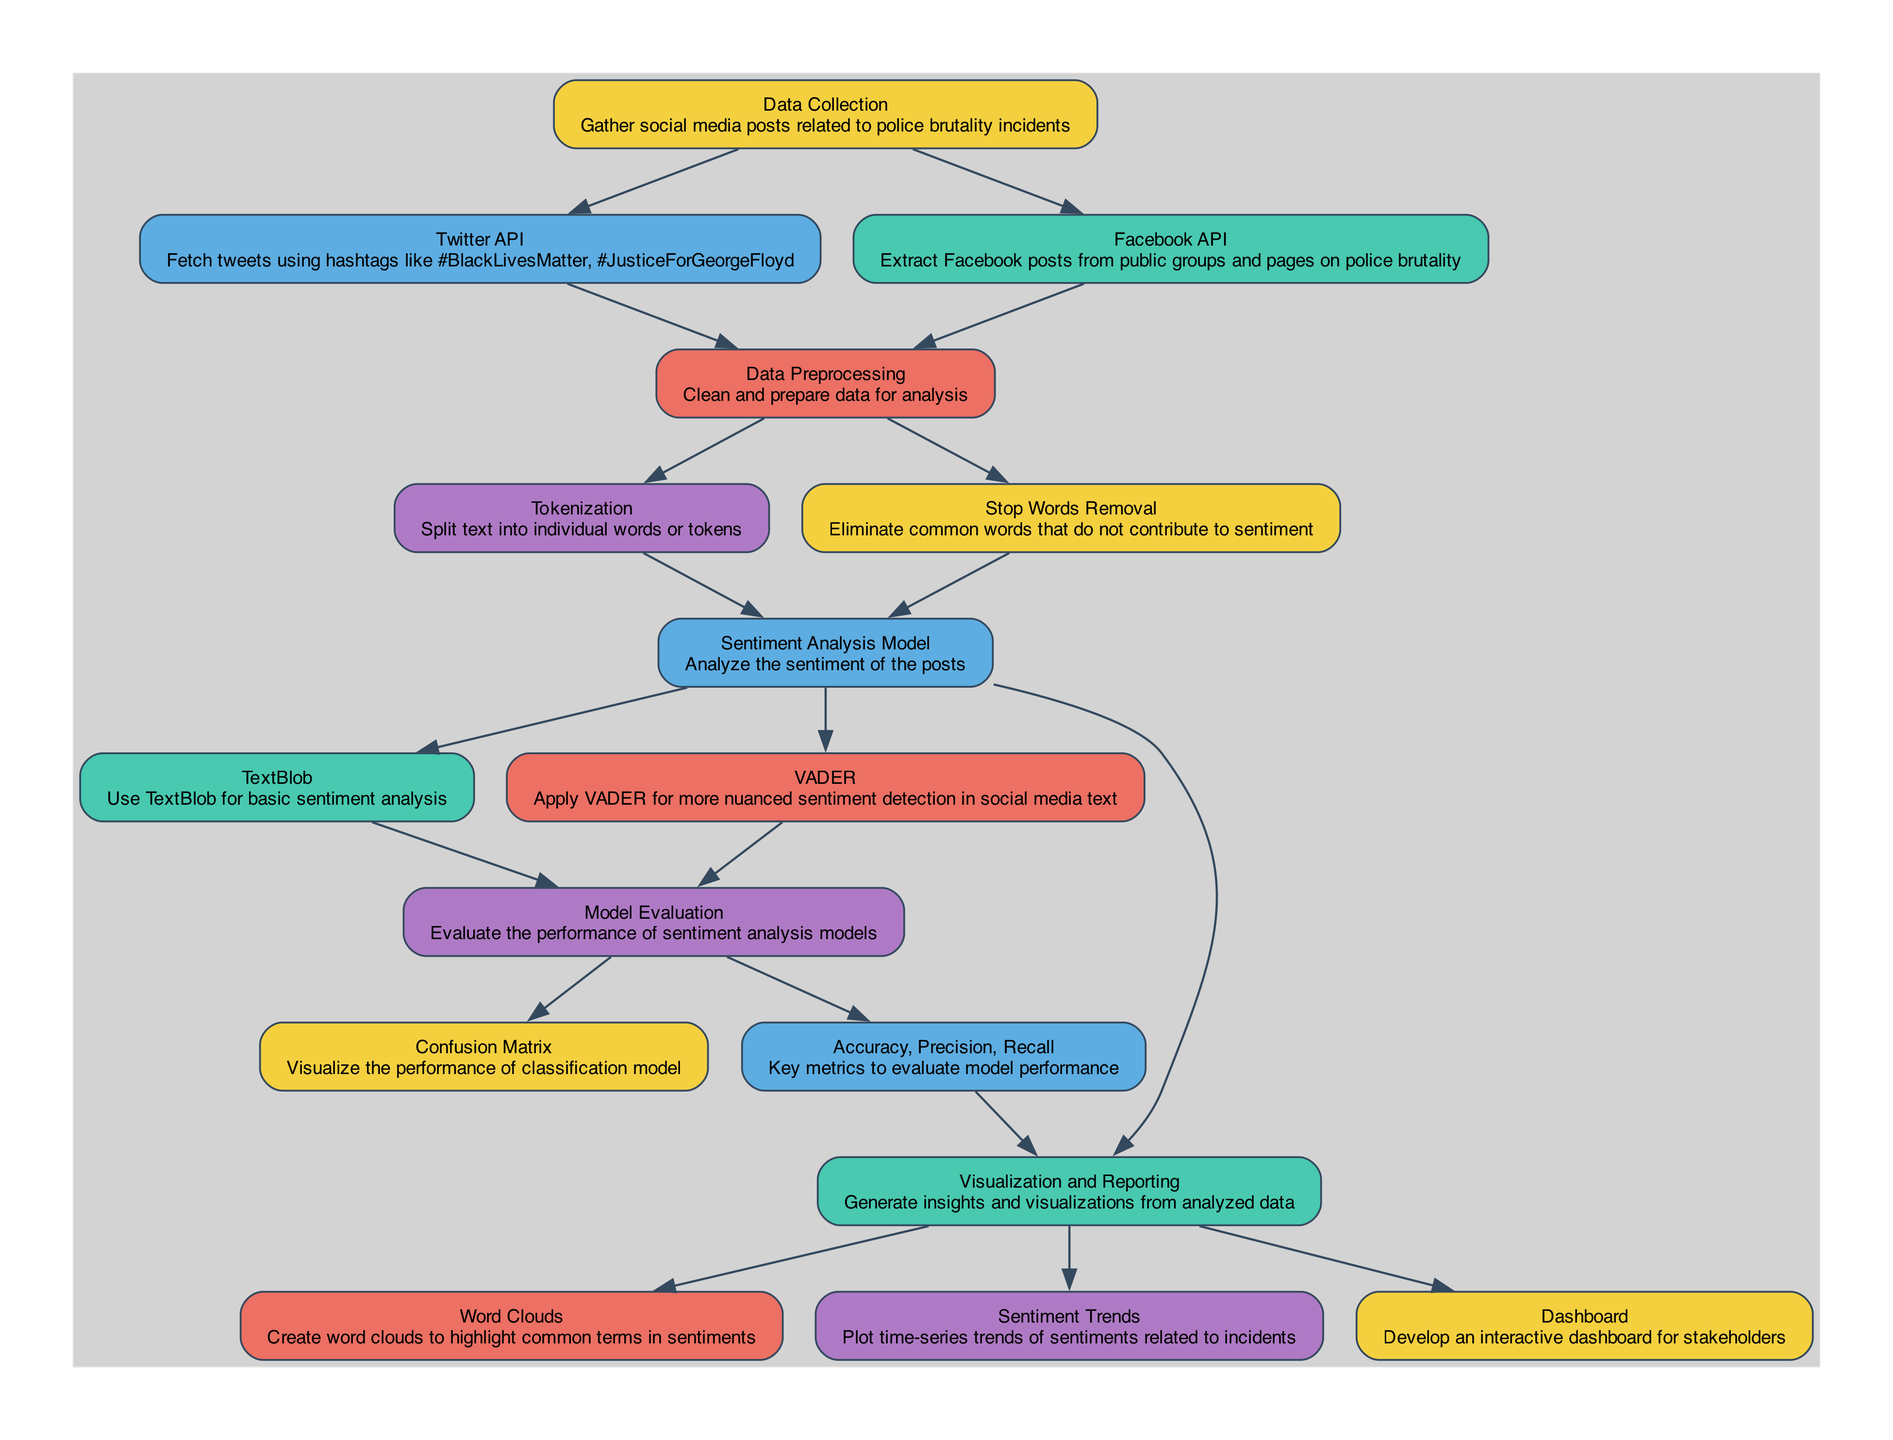What is the first step in the process? The diagram indicates that "Data Collection" is the first node, which involves gathering social media posts related to police brutality incidents.
Answer: Data Collection How many nodes are there in total? Counting the nodes listed in the diagram, there are 16 nodes representing different stages in the sentiment analysis process.
Answer: 16 What is the relationship between Data Preprocessing and Tokenization? Data Preprocessing is a prerequisite for Tokenization as indicated by the edge that connects the two, showing that preprocessing must occur before tokenization can take place.
Answer: Data Preprocessing → Tokenization Which sentiment analysis model uses TextBlob? The diagram shows that TextBlob is part of the sentiment analysis process that follows the "Sentiment Analysis Model," which uses TextBlob for basic sentiment analysis.
Answer: TextBlob What metrics are used for model evaluation? The metrics for evaluating model performance include Accuracy, Precision, and Recall, as specified by the node that elaborates on these key performance indicators.
Answer: Accuracy, Precision, Recall What is plotted in Sentiment Trends? Sentiment Trends focuses on plotting time-series trends of sentiments related to incidents of police brutality, which helps visualize how sentiment varies over time.
Answer: Time-series trends of sentiments How do we visualize the performance of the sentiment models? The performance of the sentiment analysis models is visualized using a Confusion Matrix, which allows assessment of how well the models classify the sentiments.
Answer: Confusion Matrix What is the purpose of the Dashboard node? The Dashboard node is intended to develop an interactive dashboard for stakeholders, facilitating access to insights and visualizations from data analysis.
Answer: Interactive dashboard for stakeholders What kind of posts are fetched using the Twitter API? The Twitter API is utilized to fetch tweets that use specific hashtags such as #BlackLivesMatter and #JusticeForGeorgeFloyd related to police brutality.
Answer: Tweets with hashtags 